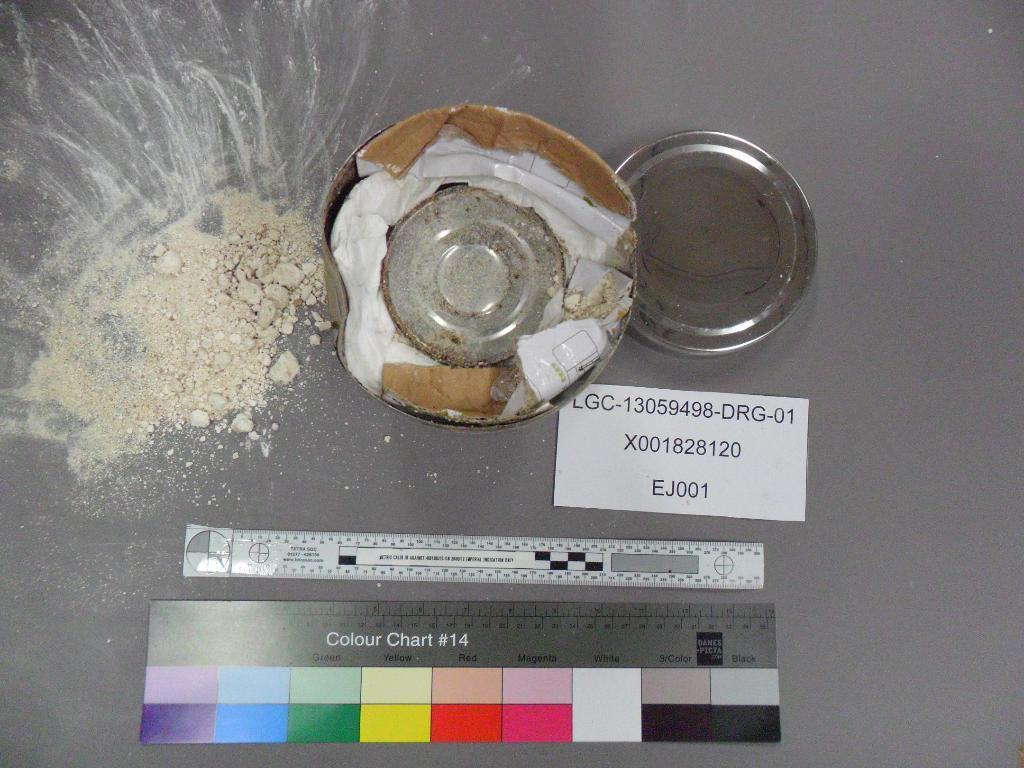Can you describe this image briefly? This is a zoomed in picture. In the center we can see the plates, some powder and some papers are placed on the top of an object. 